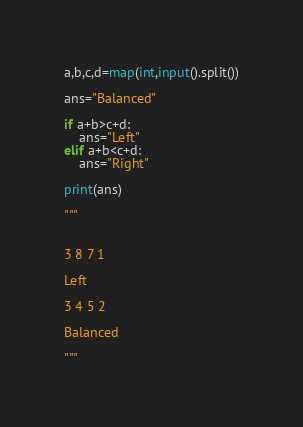<code> <loc_0><loc_0><loc_500><loc_500><_Python_>a,b,c,d=map(int,input().split())

ans="Balanced"

if a+b>c+d:
    ans="Left"
elif a+b<c+d:
    ans="Right"

print(ans)

"""


3 8 7 1

Left

3 4 5 2

Balanced

"""</code> 